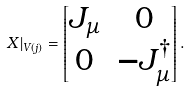Convert formula to latex. <formula><loc_0><loc_0><loc_500><loc_500>X | _ { V ( j ) } = \left [ \begin{matrix} J _ { \mu } & 0 \\ 0 & - J _ { \mu } ^ { \dagger } \end{matrix} \right ] .</formula> 